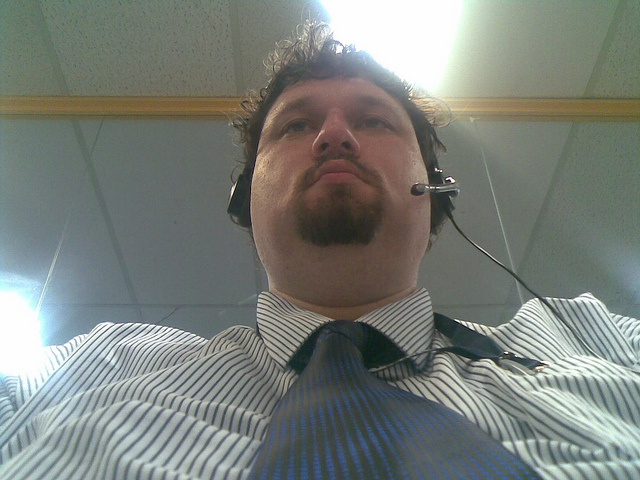Describe the objects in this image and their specific colors. I can see people in gray, darkgray, lightgray, and black tones and tie in gray, blue, and black tones in this image. 